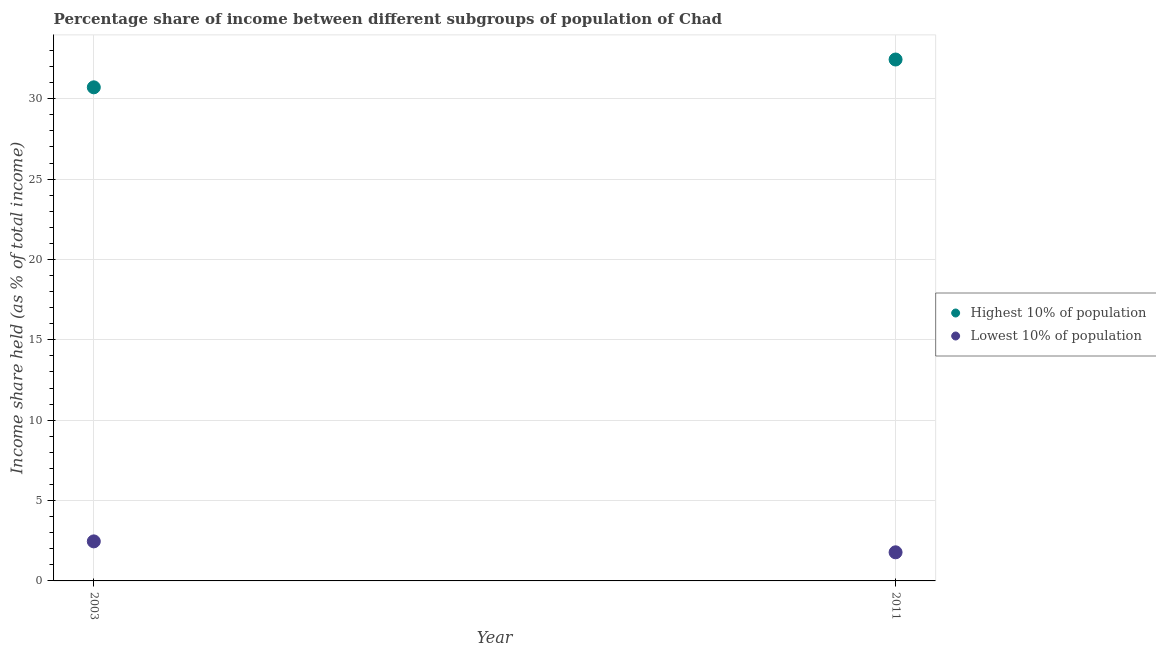How many different coloured dotlines are there?
Offer a terse response. 2. What is the income share held by highest 10% of the population in 2003?
Provide a short and direct response. 30.71. Across all years, what is the maximum income share held by lowest 10% of the population?
Provide a succinct answer. 2.46. Across all years, what is the minimum income share held by highest 10% of the population?
Keep it short and to the point. 30.71. In which year was the income share held by highest 10% of the population minimum?
Your response must be concise. 2003. What is the total income share held by highest 10% of the population in the graph?
Your response must be concise. 63.15. What is the difference between the income share held by highest 10% of the population in 2003 and that in 2011?
Provide a succinct answer. -1.73. What is the difference between the income share held by highest 10% of the population in 2011 and the income share held by lowest 10% of the population in 2003?
Your response must be concise. 29.98. What is the average income share held by highest 10% of the population per year?
Your response must be concise. 31.57. In the year 2011, what is the difference between the income share held by highest 10% of the population and income share held by lowest 10% of the population?
Your answer should be very brief. 30.66. In how many years, is the income share held by highest 10% of the population greater than 21 %?
Offer a terse response. 2. What is the ratio of the income share held by lowest 10% of the population in 2003 to that in 2011?
Ensure brevity in your answer.  1.38. Is the income share held by highest 10% of the population in 2003 less than that in 2011?
Ensure brevity in your answer.  Yes. In how many years, is the income share held by lowest 10% of the population greater than the average income share held by lowest 10% of the population taken over all years?
Offer a terse response. 1. How many dotlines are there?
Keep it short and to the point. 2. Where does the legend appear in the graph?
Your response must be concise. Center right. How many legend labels are there?
Make the answer very short. 2. How are the legend labels stacked?
Ensure brevity in your answer.  Vertical. What is the title of the graph?
Offer a terse response. Percentage share of income between different subgroups of population of Chad. What is the label or title of the X-axis?
Your response must be concise. Year. What is the label or title of the Y-axis?
Offer a very short reply. Income share held (as % of total income). What is the Income share held (as % of total income) in Highest 10% of population in 2003?
Make the answer very short. 30.71. What is the Income share held (as % of total income) in Lowest 10% of population in 2003?
Offer a terse response. 2.46. What is the Income share held (as % of total income) in Highest 10% of population in 2011?
Your answer should be compact. 32.44. What is the Income share held (as % of total income) of Lowest 10% of population in 2011?
Offer a terse response. 1.78. Across all years, what is the maximum Income share held (as % of total income) in Highest 10% of population?
Make the answer very short. 32.44. Across all years, what is the maximum Income share held (as % of total income) of Lowest 10% of population?
Provide a short and direct response. 2.46. Across all years, what is the minimum Income share held (as % of total income) in Highest 10% of population?
Make the answer very short. 30.71. Across all years, what is the minimum Income share held (as % of total income) in Lowest 10% of population?
Offer a very short reply. 1.78. What is the total Income share held (as % of total income) in Highest 10% of population in the graph?
Your response must be concise. 63.15. What is the total Income share held (as % of total income) in Lowest 10% of population in the graph?
Your answer should be compact. 4.24. What is the difference between the Income share held (as % of total income) of Highest 10% of population in 2003 and that in 2011?
Ensure brevity in your answer.  -1.73. What is the difference between the Income share held (as % of total income) of Lowest 10% of population in 2003 and that in 2011?
Keep it short and to the point. 0.68. What is the difference between the Income share held (as % of total income) in Highest 10% of population in 2003 and the Income share held (as % of total income) in Lowest 10% of population in 2011?
Your response must be concise. 28.93. What is the average Income share held (as % of total income) of Highest 10% of population per year?
Provide a short and direct response. 31.57. What is the average Income share held (as % of total income) in Lowest 10% of population per year?
Offer a terse response. 2.12. In the year 2003, what is the difference between the Income share held (as % of total income) in Highest 10% of population and Income share held (as % of total income) in Lowest 10% of population?
Provide a succinct answer. 28.25. In the year 2011, what is the difference between the Income share held (as % of total income) in Highest 10% of population and Income share held (as % of total income) in Lowest 10% of population?
Provide a succinct answer. 30.66. What is the ratio of the Income share held (as % of total income) of Highest 10% of population in 2003 to that in 2011?
Provide a succinct answer. 0.95. What is the ratio of the Income share held (as % of total income) of Lowest 10% of population in 2003 to that in 2011?
Offer a very short reply. 1.38. What is the difference between the highest and the second highest Income share held (as % of total income) in Highest 10% of population?
Give a very brief answer. 1.73. What is the difference between the highest and the second highest Income share held (as % of total income) in Lowest 10% of population?
Your answer should be very brief. 0.68. What is the difference between the highest and the lowest Income share held (as % of total income) in Highest 10% of population?
Offer a very short reply. 1.73. What is the difference between the highest and the lowest Income share held (as % of total income) of Lowest 10% of population?
Your answer should be very brief. 0.68. 